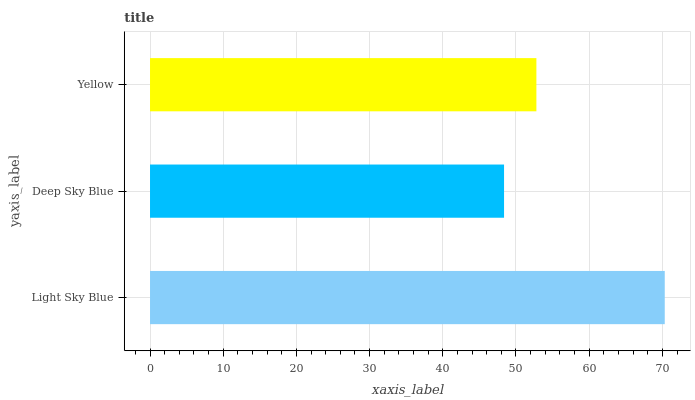Is Deep Sky Blue the minimum?
Answer yes or no. Yes. Is Light Sky Blue the maximum?
Answer yes or no. Yes. Is Yellow the minimum?
Answer yes or no. No. Is Yellow the maximum?
Answer yes or no. No. Is Yellow greater than Deep Sky Blue?
Answer yes or no. Yes. Is Deep Sky Blue less than Yellow?
Answer yes or no. Yes. Is Deep Sky Blue greater than Yellow?
Answer yes or no. No. Is Yellow less than Deep Sky Blue?
Answer yes or no. No. Is Yellow the high median?
Answer yes or no. Yes. Is Yellow the low median?
Answer yes or no. Yes. Is Light Sky Blue the high median?
Answer yes or no. No. Is Deep Sky Blue the low median?
Answer yes or no. No. 